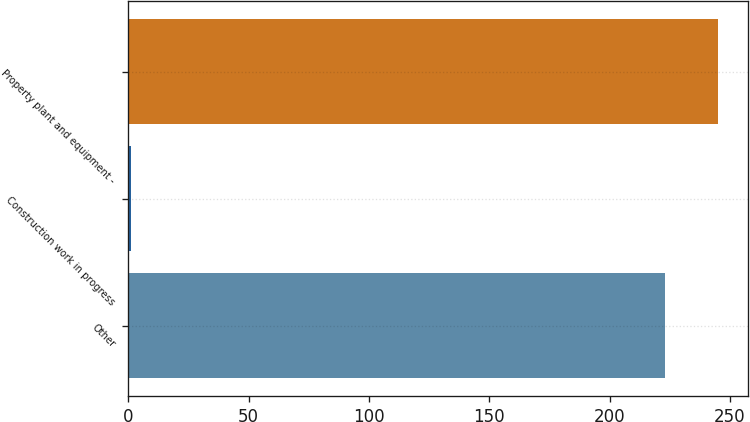Convert chart to OTSL. <chart><loc_0><loc_0><loc_500><loc_500><bar_chart><fcel>Other<fcel>Construction work in progress<fcel>Property plant and equipment -<nl><fcel>223<fcel>1<fcel>245.3<nl></chart> 